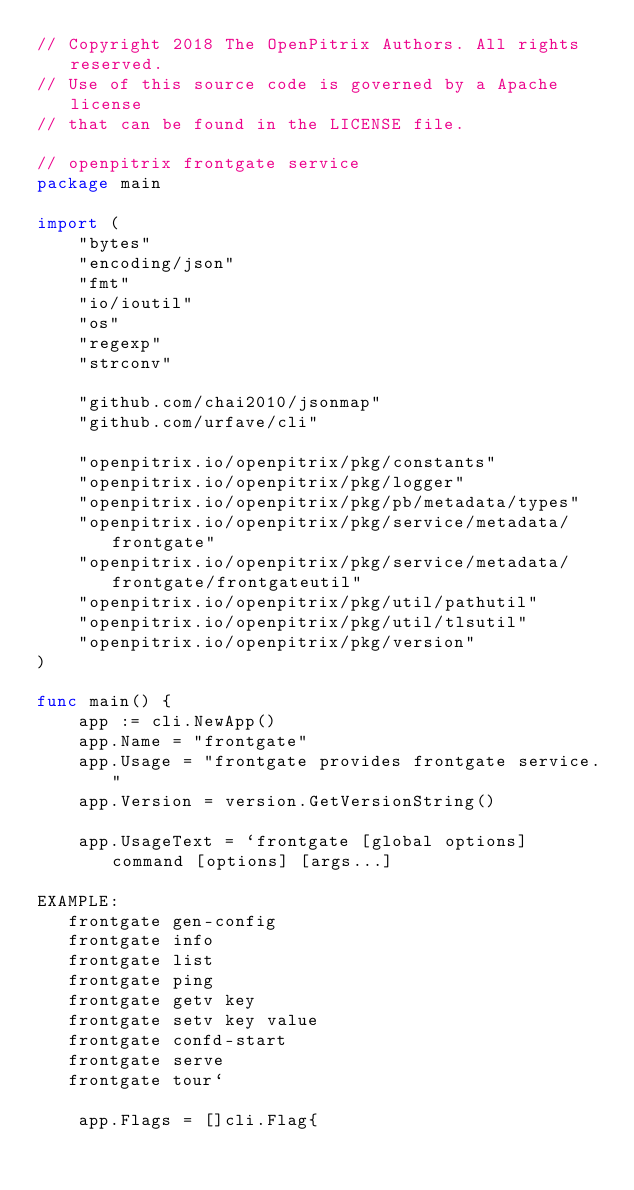Convert code to text. <code><loc_0><loc_0><loc_500><loc_500><_Go_>// Copyright 2018 The OpenPitrix Authors. All rights reserved.
// Use of this source code is governed by a Apache license
// that can be found in the LICENSE file.

// openpitrix frontgate service
package main

import (
	"bytes"
	"encoding/json"
	"fmt"
	"io/ioutil"
	"os"
	"regexp"
	"strconv"

	"github.com/chai2010/jsonmap"
	"github.com/urfave/cli"

	"openpitrix.io/openpitrix/pkg/constants"
	"openpitrix.io/openpitrix/pkg/logger"
	"openpitrix.io/openpitrix/pkg/pb/metadata/types"
	"openpitrix.io/openpitrix/pkg/service/metadata/frontgate"
	"openpitrix.io/openpitrix/pkg/service/metadata/frontgate/frontgateutil"
	"openpitrix.io/openpitrix/pkg/util/pathutil"
	"openpitrix.io/openpitrix/pkg/util/tlsutil"
	"openpitrix.io/openpitrix/pkg/version"
)

func main() {
	app := cli.NewApp()
	app.Name = "frontgate"
	app.Usage = "frontgate provides frontgate service."
	app.Version = version.GetVersionString()

	app.UsageText = `frontgate [global options] command [options] [args...]

EXAMPLE:
   frontgate gen-config
   frontgate info
   frontgate list
   frontgate ping
   frontgate getv key
   frontgate setv key value
   frontgate confd-start
   frontgate serve
   frontgate tour`

	app.Flags = []cli.Flag{</code> 